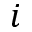<formula> <loc_0><loc_0><loc_500><loc_500>i</formula> 